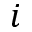<formula> <loc_0><loc_0><loc_500><loc_500>i</formula> 